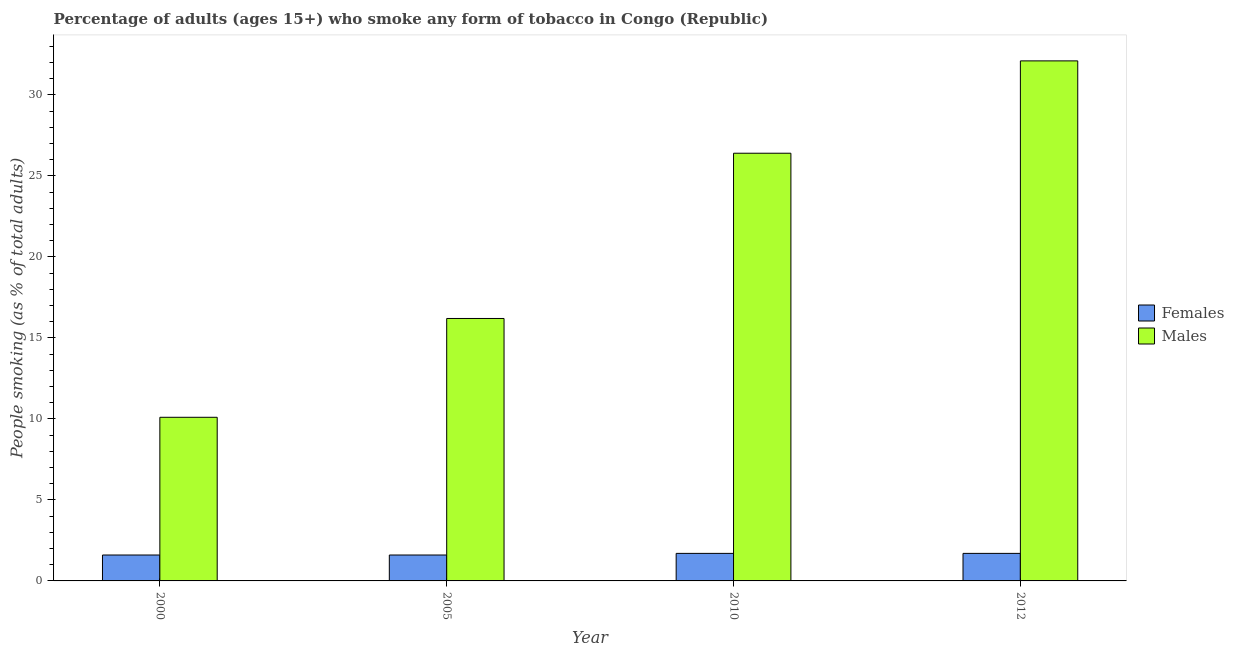How many groups of bars are there?
Give a very brief answer. 4. Are the number of bars per tick equal to the number of legend labels?
Your answer should be very brief. Yes. Are the number of bars on each tick of the X-axis equal?
Your answer should be compact. Yes. How many bars are there on the 4th tick from the left?
Keep it short and to the point. 2. How many bars are there on the 2nd tick from the right?
Make the answer very short. 2. What is the label of the 2nd group of bars from the left?
Give a very brief answer. 2005. Across all years, what is the minimum percentage of females who smoke?
Offer a terse response. 1.6. In which year was the percentage of females who smoke minimum?
Ensure brevity in your answer.  2000. What is the total percentage of females who smoke in the graph?
Ensure brevity in your answer.  6.6. What is the difference between the percentage of females who smoke in 2000 and that in 2010?
Keep it short and to the point. -0.1. What is the difference between the percentage of males who smoke in 2012 and the percentage of females who smoke in 2010?
Provide a succinct answer. 5.7. What is the average percentage of females who smoke per year?
Offer a terse response. 1.65. In the year 2005, what is the difference between the percentage of males who smoke and percentage of females who smoke?
Ensure brevity in your answer.  0. What is the ratio of the percentage of males who smoke in 2000 to that in 2010?
Offer a terse response. 0.38. Is the difference between the percentage of males who smoke in 2010 and 2012 greater than the difference between the percentage of females who smoke in 2010 and 2012?
Your response must be concise. No. What is the difference between the highest and the second highest percentage of males who smoke?
Offer a terse response. 5.7. What is the difference between the highest and the lowest percentage of males who smoke?
Make the answer very short. 22. What does the 2nd bar from the left in 2010 represents?
Offer a very short reply. Males. What does the 2nd bar from the right in 2012 represents?
Provide a succinct answer. Females. How many years are there in the graph?
Your response must be concise. 4. Where does the legend appear in the graph?
Provide a short and direct response. Center right. How many legend labels are there?
Your answer should be compact. 2. How are the legend labels stacked?
Give a very brief answer. Vertical. What is the title of the graph?
Your response must be concise. Percentage of adults (ages 15+) who smoke any form of tobacco in Congo (Republic). Does "Drinking water services" appear as one of the legend labels in the graph?
Offer a very short reply. No. What is the label or title of the X-axis?
Your response must be concise. Year. What is the label or title of the Y-axis?
Provide a short and direct response. People smoking (as % of total adults). What is the People smoking (as % of total adults) in Females in 2000?
Offer a very short reply. 1.6. What is the People smoking (as % of total adults) in Males in 2000?
Ensure brevity in your answer.  10.1. What is the People smoking (as % of total adults) of Females in 2005?
Ensure brevity in your answer.  1.6. What is the People smoking (as % of total adults) in Males in 2005?
Your response must be concise. 16.2. What is the People smoking (as % of total adults) in Females in 2010?
Provide a short and direct response. 1.7. What is the People smoking (as % of total adults) in Males in 2010?
Offer a very short reply. 26.4. What is the People smoking (as % of total adults) in Females in 2012?
Keep it short and to the point. 1.7. What is the People smoking (as % of total adults) in Males in 2012?
Your response must be concise. 32.1. Across all years, what is the maximum People smoking (as % of total adults) of Males?
Provide a succinct answer. 32.1. What is the total People smoking (as % of total adults) in Males in the graph?
Keep it short and to the point. 84.8. What is the difference between the People smoking (as % of total adults) in Males in 2000 and that in 2010?
Offer a terse response. -16.3. What is the difference between the People smoking (as % of total adults) of Females in 2000 and that in 2012?
Provide a short and direct response. -0.1. What is the difference between the People smoking (as % of total adults) in Males in 2005 and that in 2010?
Your answer should be very brief. -10.2. What is the difference between the People smoking (as % of total adults) of Males in 2005 and that in 2012?
Your answer should be compact. -15.9. What is the difference between the People smoking (as % of total adults) of Males in 2010 and that in 2012?
Give a very brief answer. -5.7. What is the difference between the People smoking (as % of total adults) in Females in 2000 and the People smoking (as % of total adults) in Males in 2005?
Your answer should be compact. -14.6. What is the difference between the People smoking (as % of total adults) in Females in 2000 and the People smoking (as % of total adults) in Males in 2010?
Ensure brevity in your answer.  -24.8. What is the difference between the People smoking (as % of total adults) of Females in 2000 and the People smoking (as % of total adults) of Males in 2012?
Your response must be concise. -30.5. What is the difference between the People smoking (as % of total adults) of Females in 2005 and the People smoking (as % of total adults) of Males in 2010?
Ensure brevity in your answer.  -24.8. What is the difference between the People smoking (as % of total adults) of Females in 2005 and the People smoking (as % of total adults) of Males in 2012?
Ensure brevity in your answer.  -30.5. What is the difference between the People smoking (as % of total adults) in Females in 2010 and the People smoking (as % of total adults) in Males in 2012?
Your response must be concise. -30.4. What is the average People smoking (as % of total adults) in Females per year?
Provide a short and direct response. 1.65. What is the average People smoking (as % of total adults) of Males per year?
Your answer should be compact. 21.2. In the year 2005, what is the difference between the People smoking (as % of total adults) in Females and People smoking (as % of total adults) in Males?
Give a very brief answer. -14.6. In the year 2010, what is the difference between the People smoking (as % of total adults) of Females and People smoking (as % of total adults) of Males?
Make the answer very short. -24.7. In the year 2012, what is the difference between the People smoking (as % of total adults) of Females and People smoking (as % of total adults) of Males?
Your answer should be compact. -30.4. What is the ratio of the People smoking (as % of total adults) of Females in 2000 to that in 2005?
Make the answer very short. 1. What is the ratio of the People smoking (as % of total adults) of Males in 2000 to that in 2005?
Provide a succinct answer. 0.62. What is the ratio of the People smoking (as % of total adults) in Females in 2000 to that in 2010?
Provide a short and direct response. 0.94. What is the ratio of the People smoking (as % of total adults) of Males in 2000 to that in 2010?
Your answer should be very brief. 0.38. What is the ratio of the People smoking (as % of total adults) of Males in 2000 to that in 2012?
Offer a very short reply. 0.31. What is the ratio of the People smoking (as % of total adults) of Females in 2005 to that in 2010?
Your answer should be very brief. 0.94. What is the ratio of the People smoking (as % of total adults) of Males in 2005 to that in 2010?
Your answer should be very brief. 0.61. What is the ratio of the People smoking (as % of total adults) in Females in 2005 to that in 2012?
Provide a succinct answer. 0.94. What is the ratio of the People smoking (as % of total adults) of Males in 2005 to that in 2012?
Your response must be concise. 0.5. What is the ratio of the People smoking (as % of total adults) in Males in 2010 to that in 2012?
Provide a succinct answer. 0.82. What is the difference between the highest and the second highest People smoking (as % of total adults) in Females?
Make the answer very short. 0. What is the difference between the highest and the lowest People smoking (as % of total adults) in Females?
Your answer should be compact. 0.1. What is the difference between the highest and the lowest People smoking (as % of total adults) of Males?
Give a very brief answer. 22. 